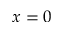Convert formula to latex. <formula><loc_0><loc_0><loc_500><loc_500>x = 0</formula> 